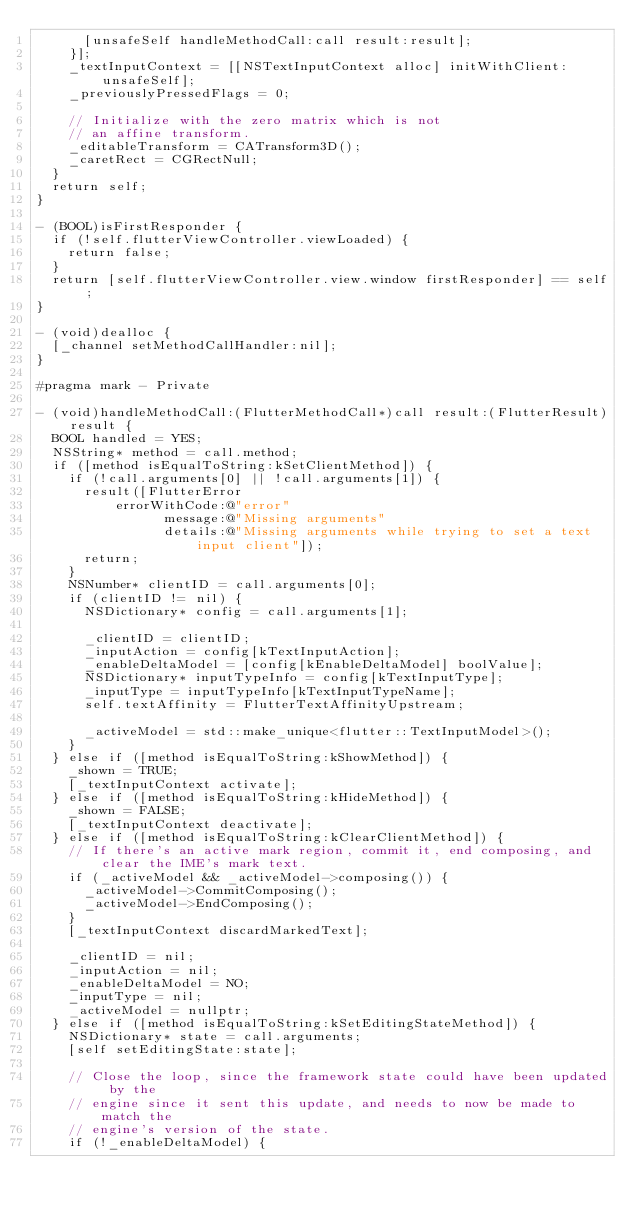Convert code to text. <code><loc_0><loc_0><loc_500><loc_500><_ObjectiveC_>      [unsafeSelf handleMethodCall:call result:result];
    }];
    _textInputContext = [[NSTextInputContext alloc] initWithClient:unsafeSelf];
    _previouslyPressedFlags = 0;

    // Initialize with the zero matrix which is not
    // an affine transform.
    _editableTransform = CATransform3D();
    _caretRect = CGRectNull;
  }
  return self;
}

- (BOOL)isFirstResponder {
  if (!self.flutterViewController.viewLoaded) {
    return false;
  }
  return [self.flutterViewController.view.window firstResponder] == self;
}

- (void)dealloc {
  [_channel setMethodCallHandler:nil];
}

#pragma mark - Private

- (void)handleMethodCall:(FlutterMethodCall*)call result:(FlutterResult)result {
  BOOL handled = YES;
  NSString* method = call.method;
  if ([method isEqualToString:kSetClientMethod]) {
    if (!call.arguments[0] || !call.arguments[1]) {
      result([FlutterError
          errorWithCode:@"error"
                message:@"Missing arguments"
                details:@"Missing arguments while trying to set a text input client"]);
      return;
    }
    NSNumber* clientID = call.arguments[0];
    if (clientID != nil) {
      NSDictionary* config = call.arguments[1];

      _clientID = clientID;
      _inputAction = config[kTextInputAction];
      _enableDeltaModel = [config[kEnableDeltaModel] boolValue];
      NSDictionary* inputTypeInfo = config[kTextInputType];
      _inputType = inputTypeInfo[kTextInputTypeName];
      self.textAffinity = FlutterTextAffinityUpstream;

      _activeModel = std::make_unique<flutter::TextInputModel>();
    }
  } else if ([method isEqualToString:kShowMethod]) {
    _shown = TRUE;
    [_textInputContext activate];
  } else if ([method isEqualToString:kHideMethod]) {
    _shown = FALSE;
    [_textInputContext deactivate];
  } else if ([method isEqualToString:kClearClientMethod]) {
    // If there's an active mark region, commit it, end composing, and clear the IME's mark text.
    if (_activeModel && _activeModel->composing()) {
      _activeModel->CommitComposing();
      _activeModel->EndComposing();
    }
    [_textInputContext discardMarkedText];

    _clientID = nil;
    _inputAction = nil;
    _enableDeltaModel = NO;
    _inputType = nil;
    _activeModel = nullptr;
  } else if ([method isEqualToString:kSetEditingStateMethod]) {
    NSDictionary* state = call.arguments;
    [self setEditingState:state];

    // Close the loop, since the framework state could have been updated by the
    // engine since it sent this update, and needs to now be made to match the
    // engine's version of the state.
    if (!_enableDeltaModel) {</code> 